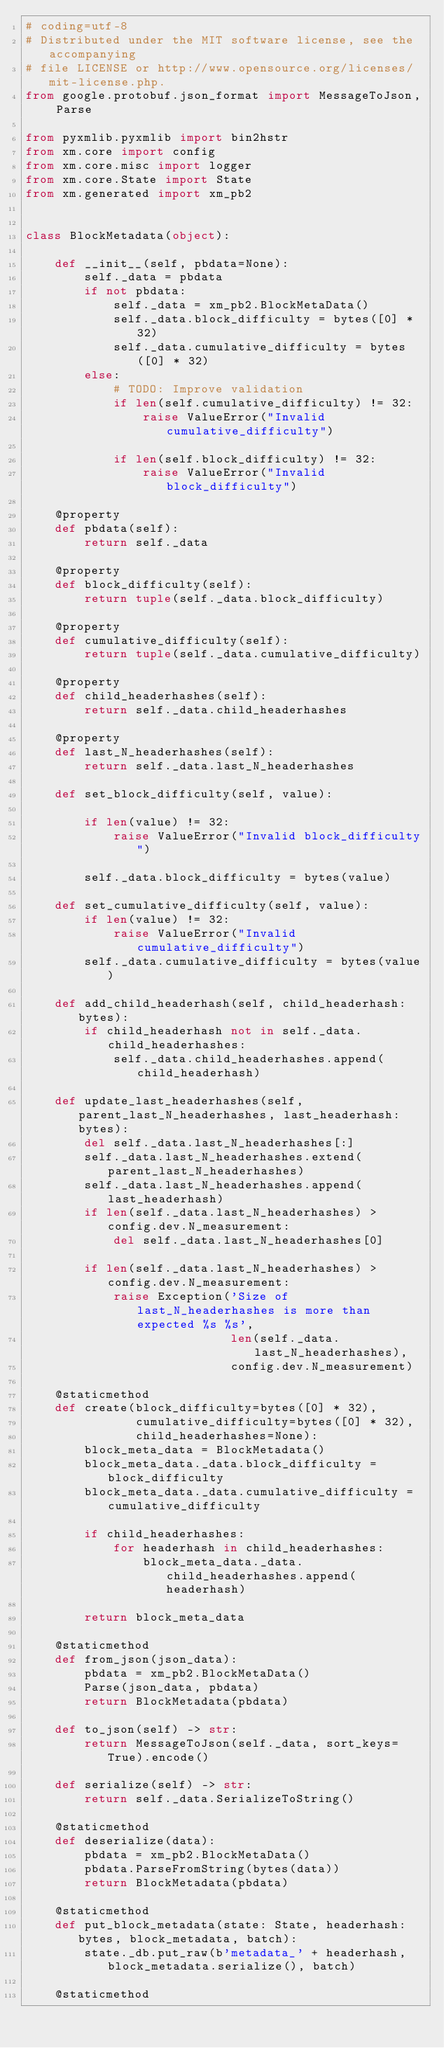<code> <loc_0><loc_0><loc_500><loc_500><_Python_># coding=utf-8
# Distributed under the MIT software license, see the accompanying
# file LICENSE or http://www.opensource.org/licenses/mit-license.php.
from google.protobuf.json_format import MessageToJson, Parse

from pyxmlib.pyxmlib import bin2hstr
from xm.core import config
from xm.core.misc import logger
from xm.core.State import State
from xm.generated import xm_pb2


class BlockMetadata(object):

    def __init__(self, pbdata=None):
        self._data = pbdata
        if not pbdata:
            self._data = xm_pb2.BlockMetaData()
            self._data.block_difficulty = bytes([0] * 32)
            self._data.cumulative_difficulty = bytes([0] * 32)
        else:
            # TODO: Improve validation
            if len(self.cumulative_difficulty) != 32:
                raise ValueError("Invalid cumulative_difficulty")

            if len(self.block_difficulty) != 32:
                raise ValueError("Invalid block_difficulty")

    @property
    def pbdata(self):
        return self._data

    @property
    def block_difficulty(self):
        return tuple(self._data.block_difficulty)

    @property
    def cumulative_difficulty(self):
        return tuple(self._data.cumulative_difficulty)

    @property
    def child_headerhashes(self):
        return self._data.child_headerhashes

    @property
    def last_N_headerhashes(self):
        return self._data.last_N_headerhashes

    def set_block_difficulty(self, value):

        if len(value) != 32:
            raise ValueError("Invalid block_difficulty")

        self._data.block_difficulty = bytes(value)

    def set_cumulative_difficulty(self, value):
        if len(value) != 32:
            raise ValueError("Invalid cumulative_difficulty")
        self._data.cumulative_difficulty = bytes(value)

    def add_child_headerhash(self, child_headerhash: bytes):
        if child_headerhash not in self._data.child_headerhashes:
            self._data.child_headerhashes.append(child_headerhash)

    def update_last_headerhashes(self, parent_last_N_headerhashes, last_headerhash: bytes):
        del self._data.last_N_headerhashes[:]
        self._data.last_N_headerhashes.extend(parent_last_N_headerhashes)
        self._data.last_N_headerhashes.append(last_headerhash)
        if len(self._data.last_N_headerhashes) > config.dev.N_measurement:
            del self._data.last_N_headerhashes[0]

        if len(self._data.last_N_headerhashes) > config.dev.N_measurement:
            raise Exception('Size of last_N_headerhashes is more than expected %s %s',
                            len(self._data.last_N_headerhashes),
                            config.dev.N_measurement)

    @staticmethod
    def create(block_difficulty=bytes([0] * 32),
               cumulative_difficulty=bytes([0] * 32),
               child_headerhashes=None):
        block_meta_data = BlockMetadata()
        block_meta_data._data.block_difficulty = block_difficulty
        block_meta_data._data.cumulative_difficulty = cumulative_difficulty

        if child_headerhashes:
            for headerhash in child_headerhashes:
                block_meta_data._data.child_headerhashes.append(headerhash)

        return block_meta_data

    @staticmethod
    def from_json(json_data):
        pbdata = xm_pb2.BlockMetaData()
        Parse(json_data, pbdata)
        return BlockMetadata(pbdata)

    def to_json(self) -> str:
        return MessageToJson(self._data, sort_keys=True).encode()

    def serialize(self) -> str:
        return self._data.SerializeToString()

    @staticmethod
    def deserialize(data):
        pbdata = xm_pb2.BlockMetaData()
        pbdata.ParseFromString(bytes(data))
        return BlockMetadata(pbdata)

    @staticmethod
    def put_block_metadata(state: State, headerhash: bytes, block_metadata, batch):
        state._db.put_raw(b'metadata_' + headerhash, block_metadata.serialize(), batch)

    @staticmethod</code> 